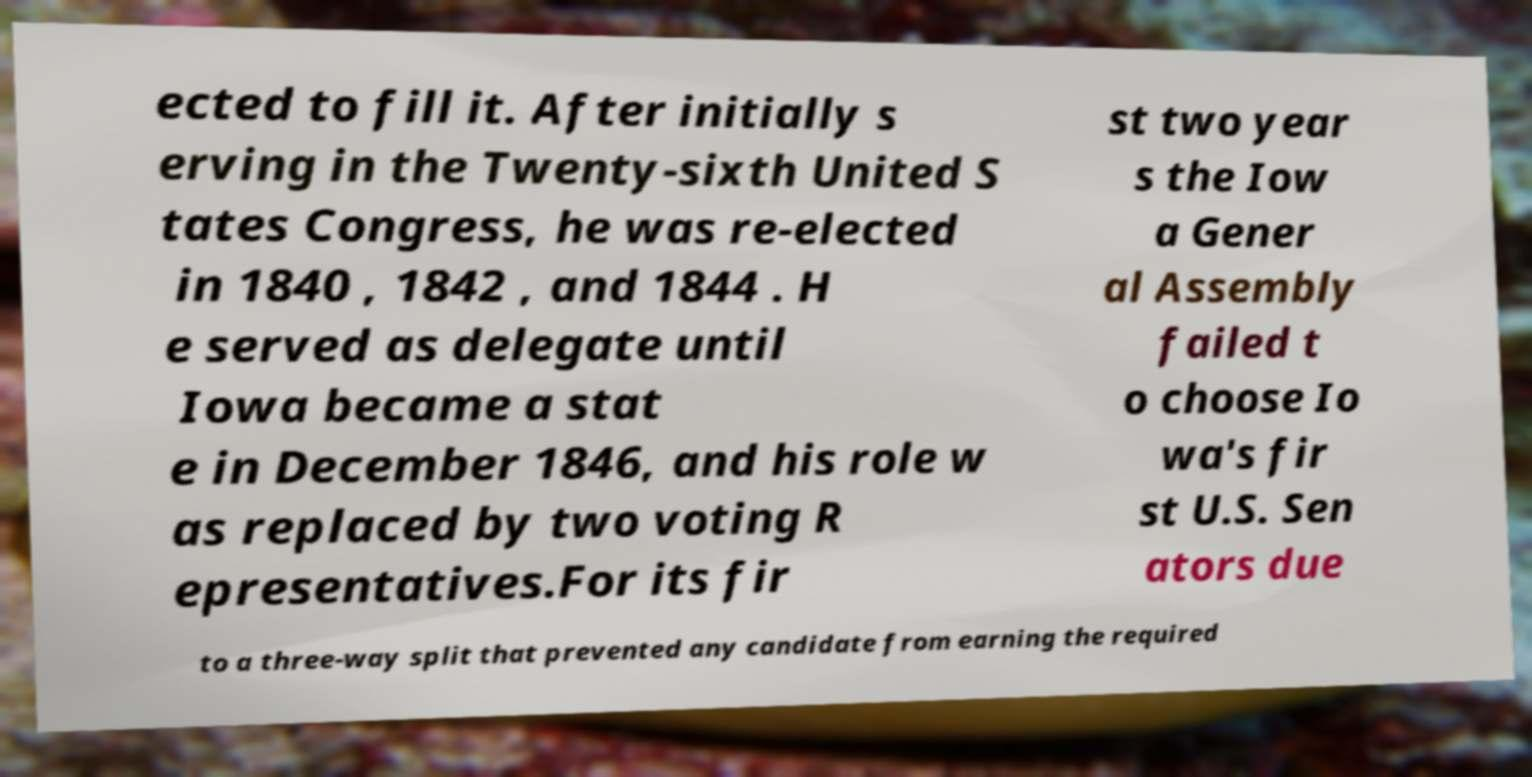I need the written content from this picture converted into text. Can you do that? ected to fill it. After initially s erving in the Twenty-sixth United S tates Congress, he was re-elected in 1840 , 1842 , and 1844 . H e served as delegate until Iowa became a stat e in December 1846, and his role w as replaced by two voting R epresentatives.For its fir st two year s the Iow a Gener al Assembly failed t o choose Io wa's fir st U.S. Sen ators due to a three-way split that prevented any candidate from earning the required 